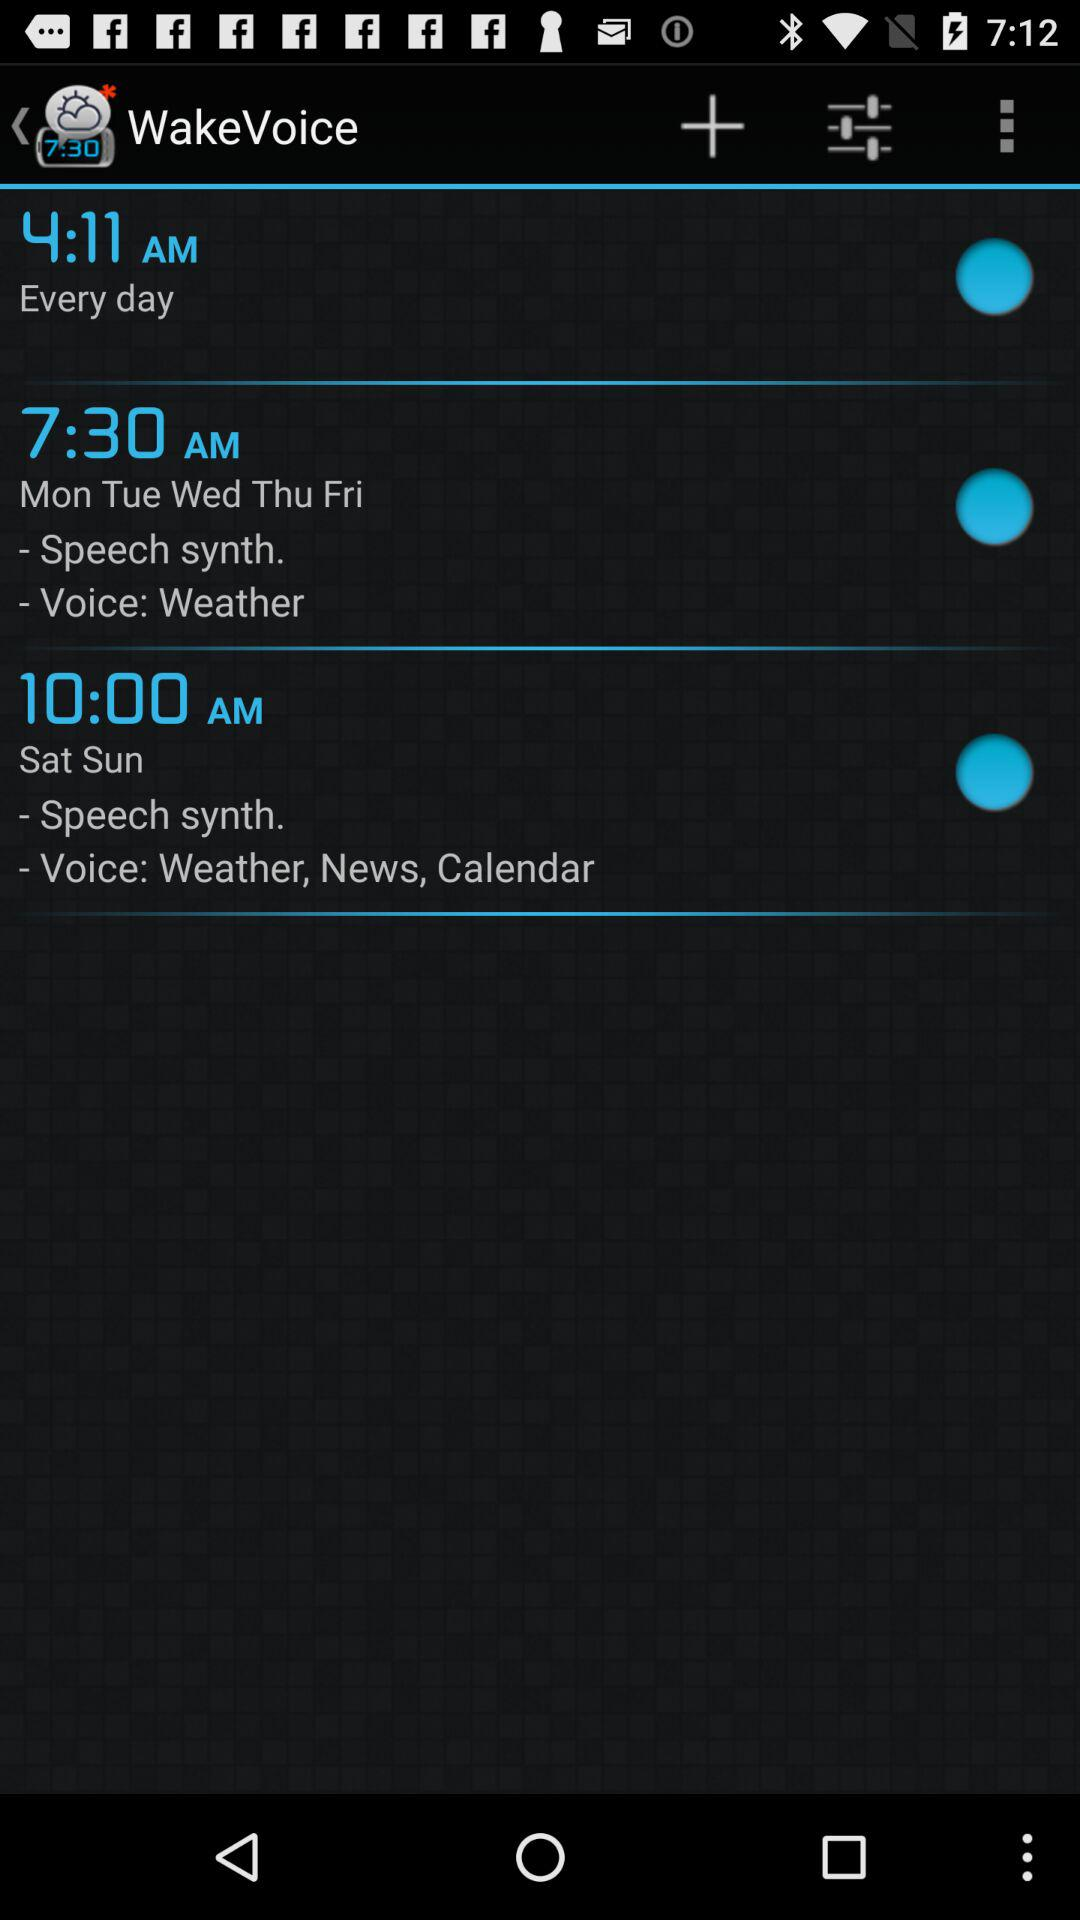What is the name of the application? The application name is "WakeVoice". 